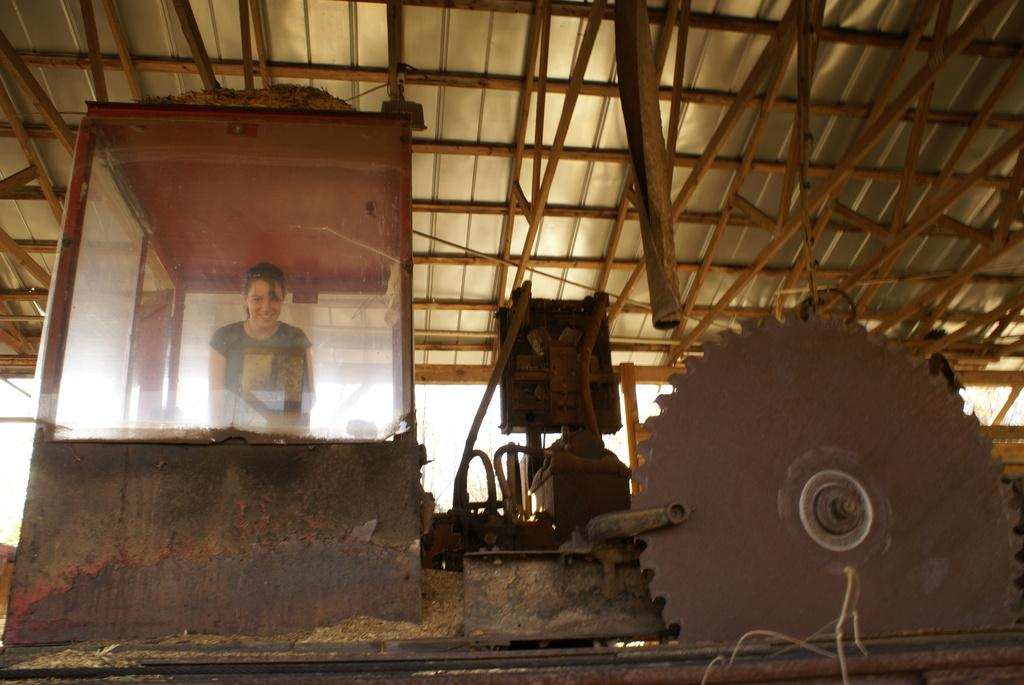What is the lady in the image doing? The lady is in a glass cabin in the image. What can be seen on the right side of the image? There are machines on the right side of the image. What type of structure is at the top of the image? There is a shed with rods at the top of the image. What type of toothbrush is the lady using in the image? There is no toothbrush present in the image. Can you see any blood on the machines in the image? There is no blood visible in the image. 